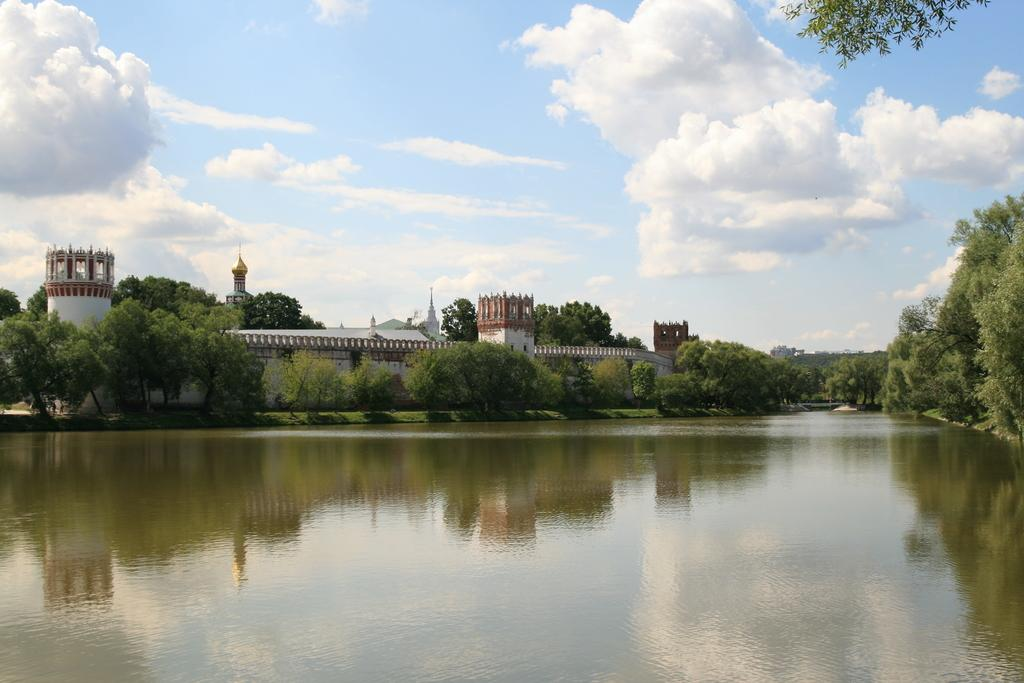What type of natural feature is at the bottom of the image? There is a river at the bottom of the image. What structures can be seen in the background of the image? There are buildings in the background of the image. What type of vegetation is present in the background of the image? There are trees in the background of the image. What is visible at the top of the image? The sky is visible at the top of the image. What does the hole in the river taste like in the image? There is no hole in the river in the image, so it cannot be tasted. 